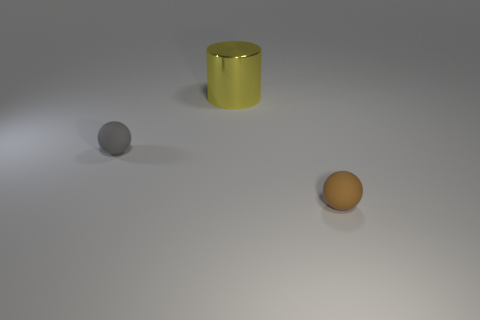What is the size of the matte object that is to the left of the matte sphere that is right of the large yellow cylinder on the left side of the brown ball?
Offer a very short reply. Small. What number of objects are either gray spheres or tiny matte balls that are left of the brown object?
Your response must be concise. 1. What is the color of the cylinder?
Keep it short and to the point. Yellow. What color is the rubber ball to the left of the big yellow metal cylinder?
Make the answer very short. Gray. There is a matte ball that is on the right side of the big object; what number of tiny brown matte things are to the left of it?
Offer a terse response. 0. Does the yellow object have the same size as the sphere to the left of the small brown object?
Offer a very short reply. No. Is there a cylinder of the same size as the gray sphere?
Your response must be concise. No. What number of things are either brown matte spheres or big yellow metallic cylinders?
Provide a short and direct response. 2. There is a object that is behind the gray rubber sphere; does it have the same size as the rubber sphere right of the big shiny object?
Ensure brevity in your answer.  No. Are there any other big things of the same shape as the yellow thing?
Your response must be concise. No. 